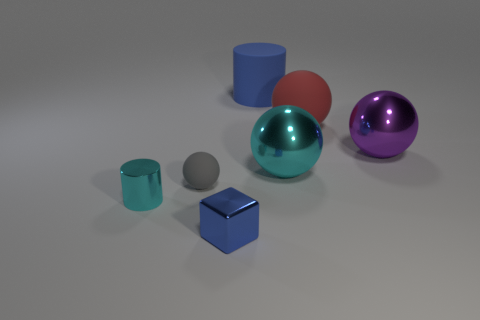What is the size of the shiny ball that is the same color as the tiny metallic cylinder?
Your answer should be compact. Large. There is a rubber thing that is the same color as the tiny cube; what is its shape?
Make the answer very short. Cylinder. What number of objects are brown objects or balls?
Offer a terse response. 4. There is a cyan thing that is on the left side of the blue block; is its shape the same as the cyan shiny object that is on the right side of the tiny metal cube?
Offer a very short reply. No. There is a matte object to the left of the small blue cube; what shape is it?
Ensure brevity in your answer.  Sphere. Are there the same number of tiny objects behind the cyan cylinder and small cylinders that are right of the big blue rubber thing?
Your response must be concise. No. What number of objects are either small rubber cubes or rubber things that are on the left side of the large blue object?
Ensure brevity in your answer.  1. There is a metallic object that is right of the large blue thing and in front of the big purple sphere; what shape is it?
Give a very brief answer. Sphere. There is a blue thing behind the shiny thing that is in front of the shiny cylinder; what is it made of?
Give a very brief answer. Rubber. Is the thing in front of the small cyan cylinder made of the same material as the large purple object?
Give a very brief answer. Yes. 